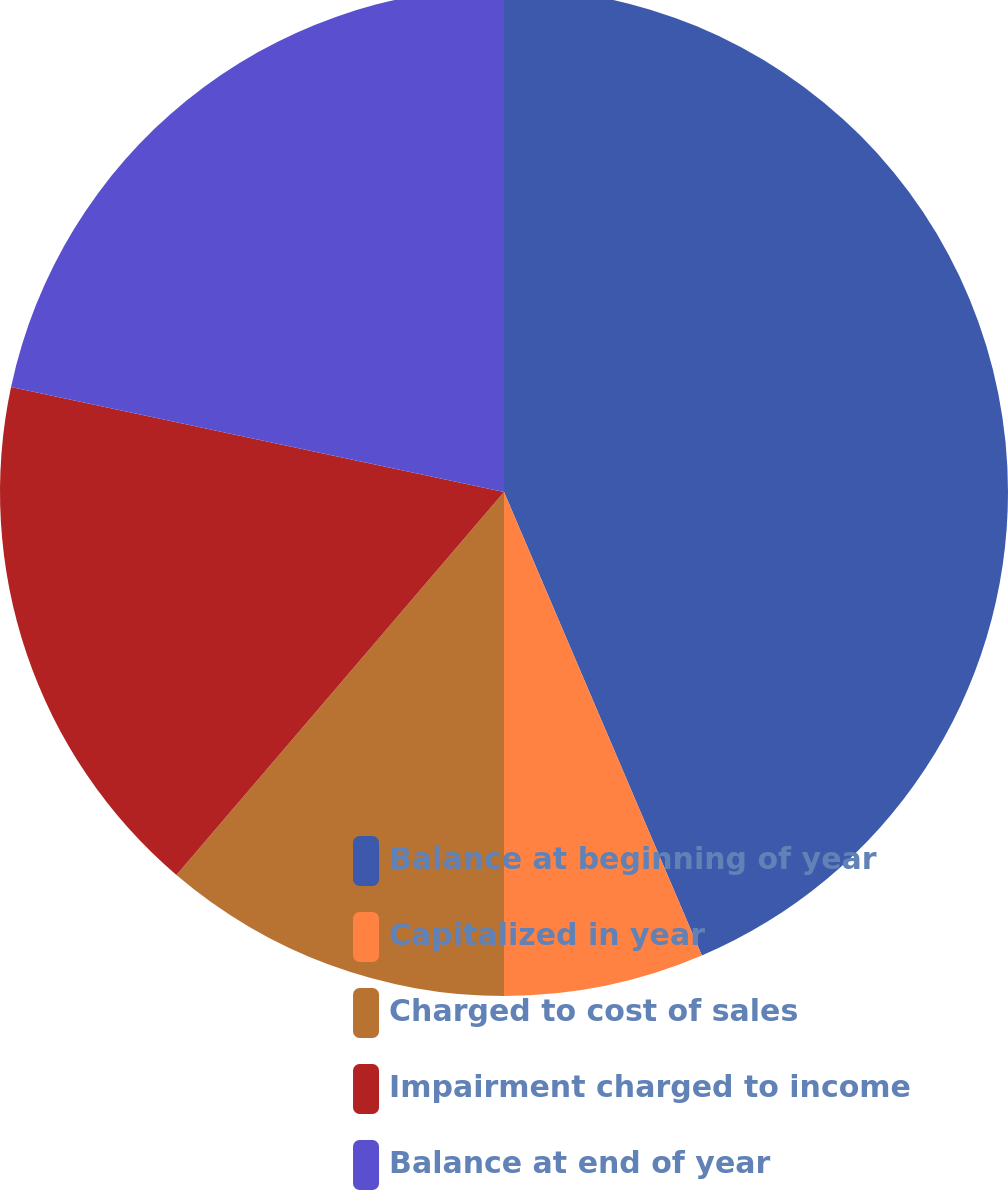Convert chart. <chart><loc_0><loc_0><loc_500><loc_500><pie_chart><fcel>Balance at beginning of year<fcel>Capitalized in year<fcel>Charged to cost of sales<fcel>Impairment charged to income<fcel>Balance at end of year<nl><fcel>43.58%<fcel>6.42%<fcel>11.26%<fcel>17.08%<fcel>21.66%<nl></chart> 